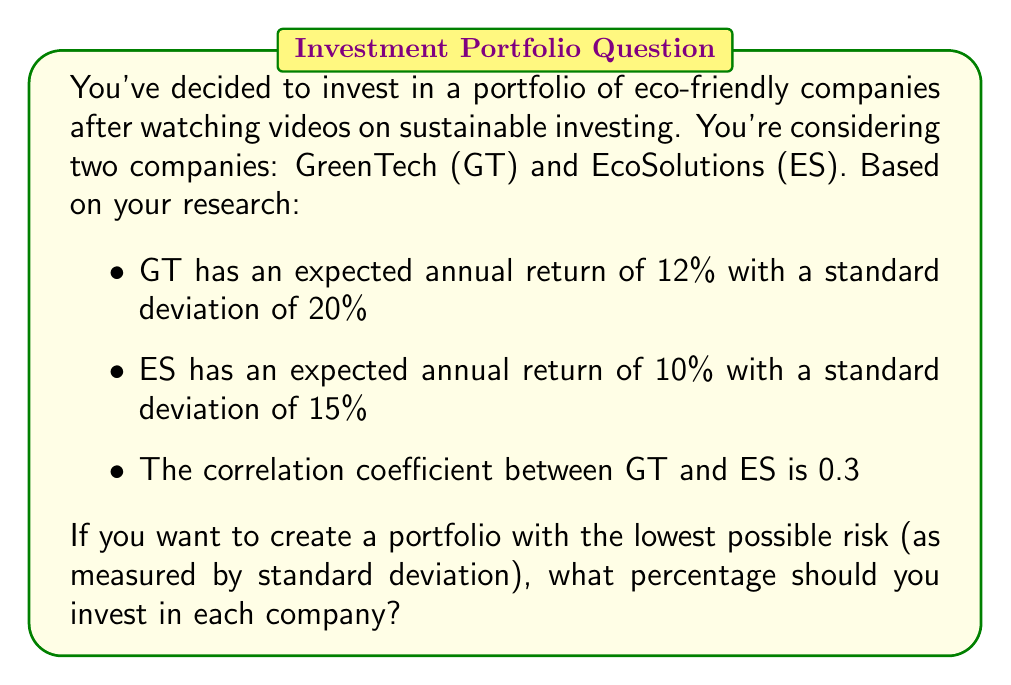Solve this math problem. To solve this problem, we'll use the concept of portfolio optimization to minimize risk. We'll follow these steps:

1) First, recall the formula for portfolio variance with two assets:

   $$\sigma_p^2 = w_1^2\sigma_1^2 + w_2^2\sigma_2^2 + 2w_1w_2\sigma_1\sigma_2\rho_{12}$$

   Where:
   $\sigma_p^2$ is the portfolio variance
   $w_1$ and $w_2$ are the weights of assets 1 and 2
   $\sigma_1$ and $\sigma_2$ are the standard deviations of assets 1 and 2
   $\rho_{12}$ is the correlation coefficient between assets 1 and 2

2) We know that $w_1 + w_2 = 1$, so we can substitute $w_2 = 1 - w_1$

3) Now, let's plug in our known values:
   $\sigma_1 = 0.20$ (GT)
   $\sigma_2 = 0.15$ (ES)
   $\rho_{12} = 0.3$

4) Our equation becomes:

   $$\sigma_p^2 = w_1^2(0.20)^2 + (1-w_1)^2(0.15)^2 + 2w_1(1-w_1)(0.20)(0.15)(0.3)$$

5) To find the minimum variance, we need to differentiate this equation with respect to $w_1$ and set it equal to zero:

   $$\frac{d\sigma_p^2}{dw_1} = 2w_1(0.20)^2 - 2(1-w_1)(0.15)^2 + 2(1-2w_1)(0.20)(0.15)(0.3) = 0$$

6) Solving this equation:

   $$0.08w_1 - 0.0450 + 0.045w_1 + 0.0180 - 0.036w_1 = 0$$
   $$0.089w_1 = 0.0270$$
   $$w_1 = 0.3034$$

7) Therefore, $w_2 = 1 - w_1 = 0.6966$

This means you should invest approximately 30.34% in GreenTech and 69.66% in EcoSolutions to minimize risk.
Answer: Invest 30.34% in GreenTech (GT) and 69.66% in EcoSolutions (ES) to create the lowest-risk portfolio. 